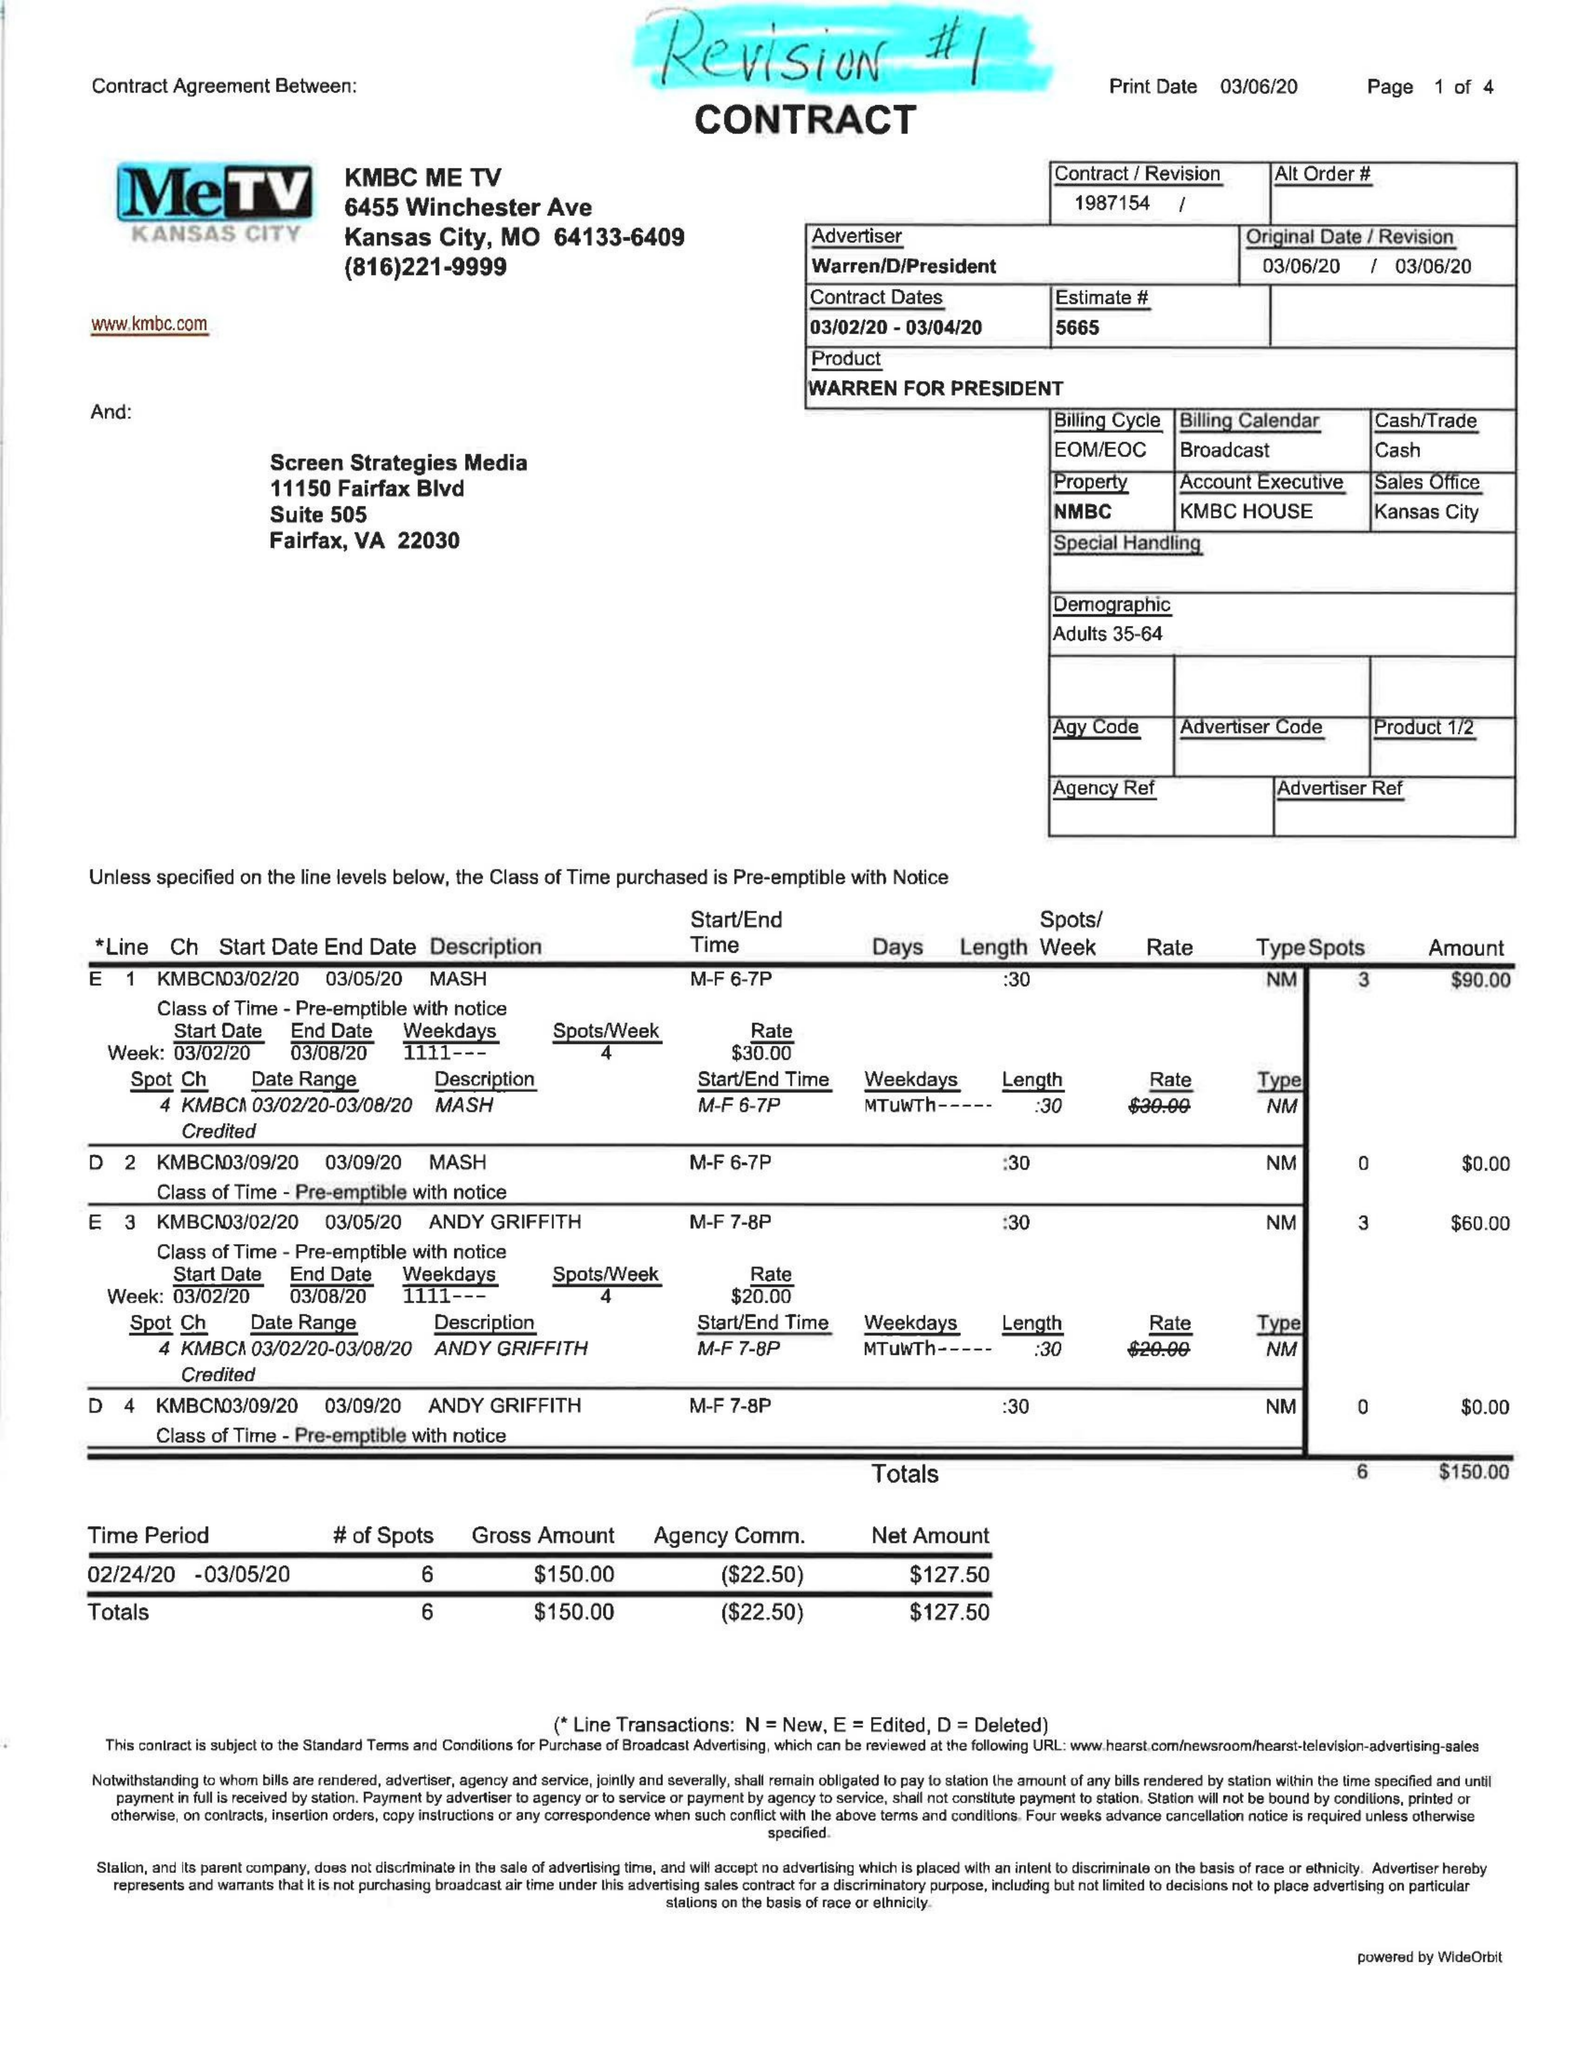What is the value for the flight_from?
Answer the question using a single word or phrase. 03/02/20 